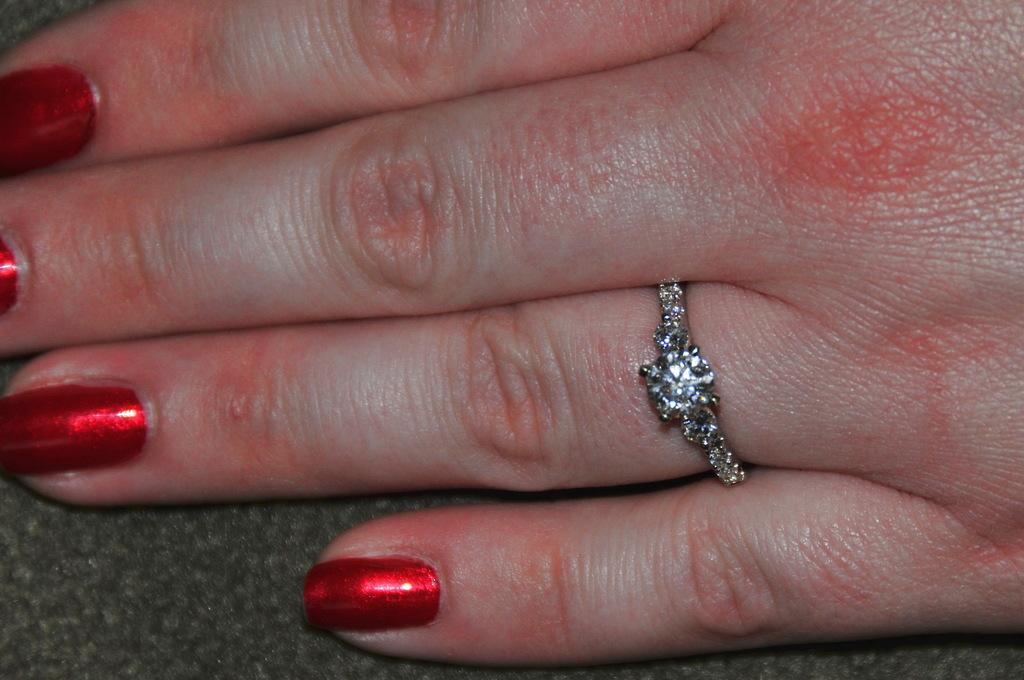What is on the fingers of the person in the image? There is nail polish on the fingers of a person in the image. What type of accessory can be seen in the image? There is a ring present in the image. What type of apple is being eaten by the cats in the image? There are no cats or apples present in the image. 